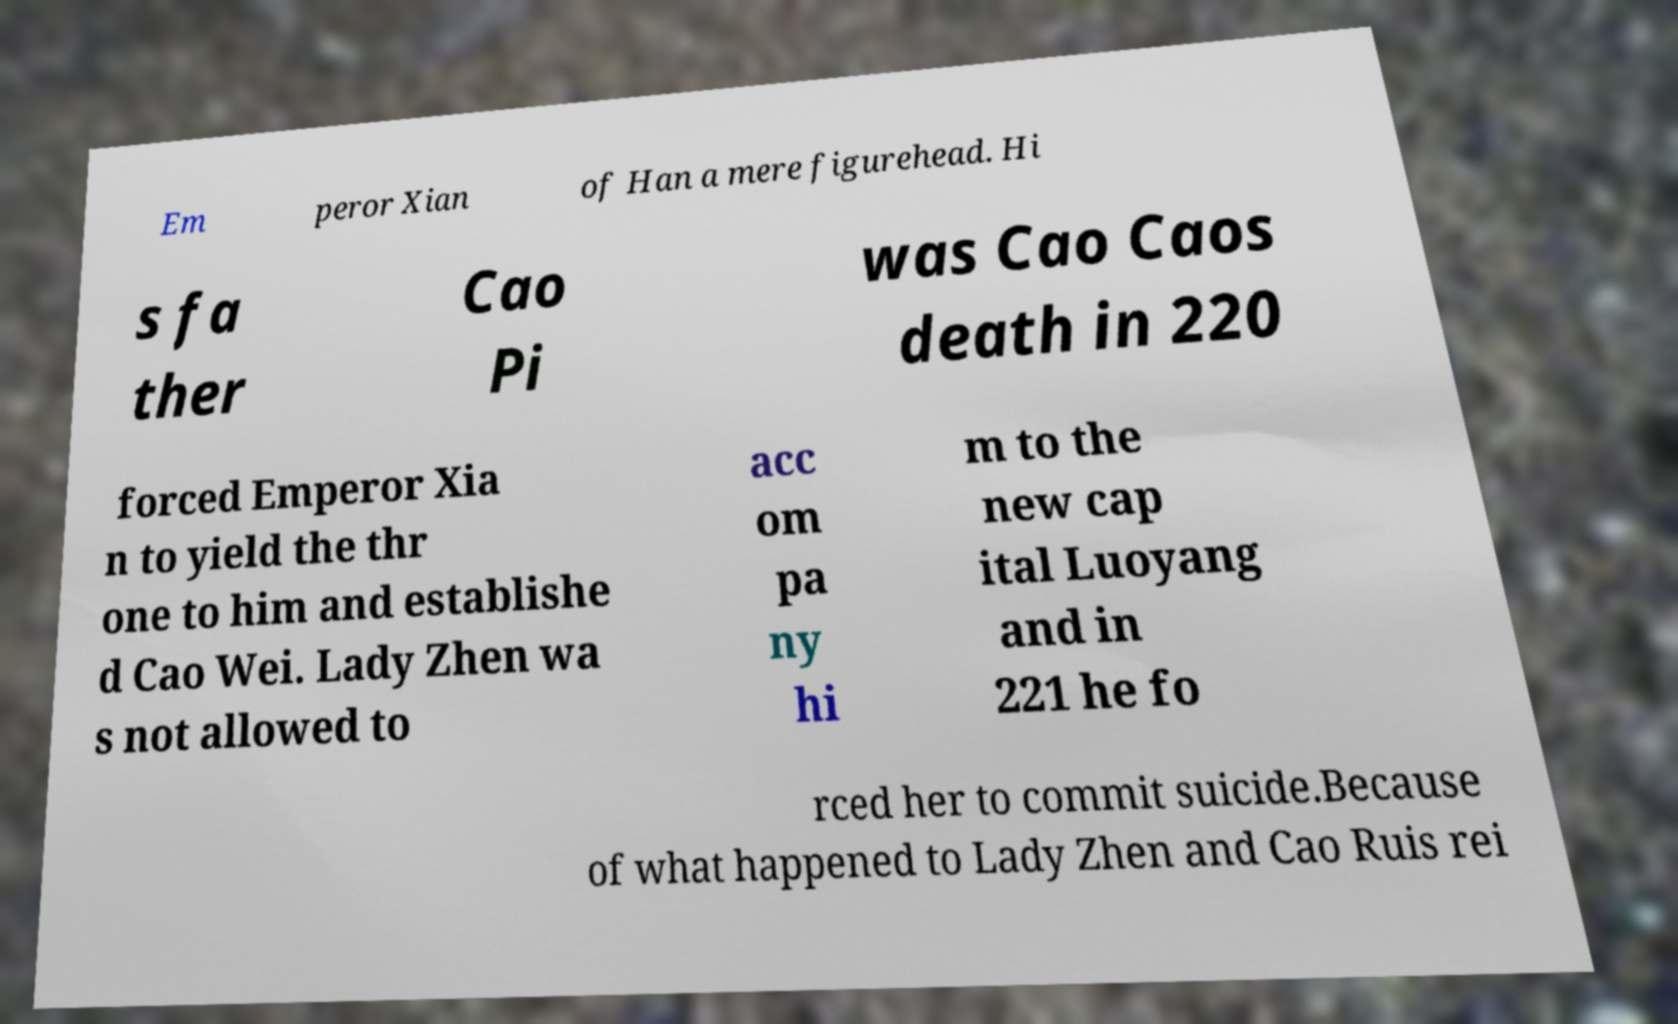There's text embedded in this image that I need extracted. Can you transcribe it verbatim? Em peror Xian of Han a mere figurehead. Hi s fa ther Cao Pi was Cao Caos death in 220 forced Emperor Xia n to yield the thr one to him and establishe d Cao Wei. Lady Zhen wa s not allowed to acc om pa ny hi m to the new cap ital Luoyang and in 221 he fo rced her to commit suicide.Because of what happened to Lady Zhen and Cao Ruis rei 